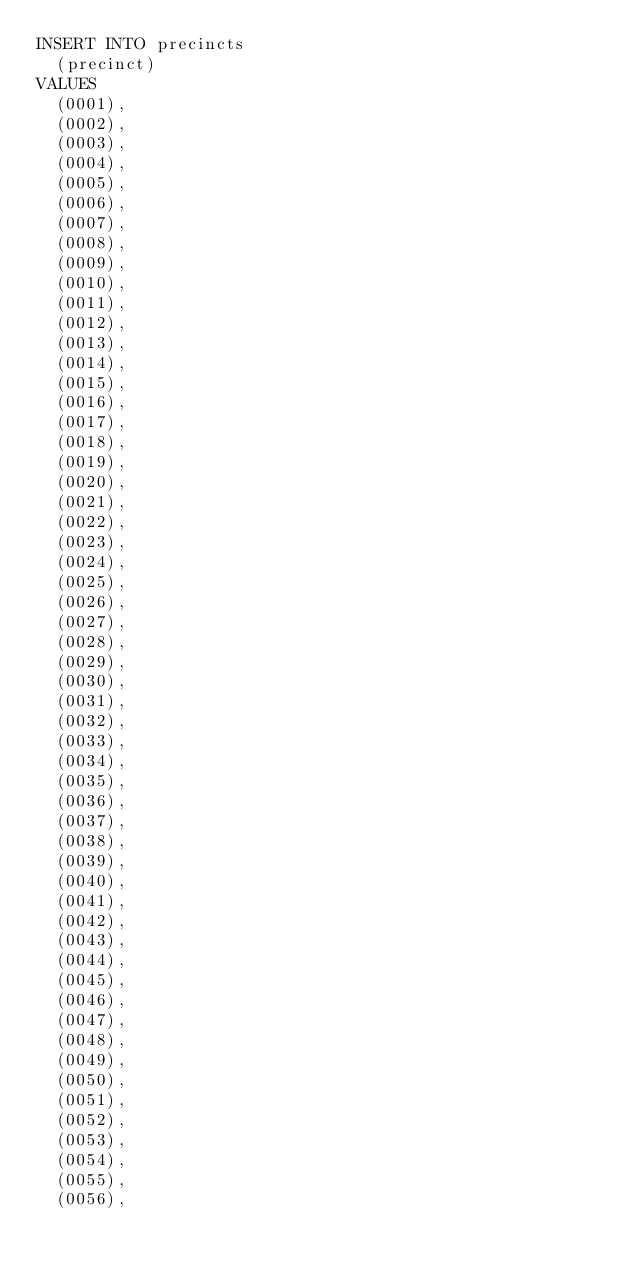<code> <loc_0><loc_0><loc_500><loc_500><_SQL_>INSERT INTO precincts
  (precinct)
VALUES
  (0001),
  (0002),
  (0003),
  (0004),
  (0005),
  (0006),
  (0007),
  (0008),
  (0009),
  (0010),
  (0011),
  (0012),
  (0013),
  (0014),
  (0015),
  (0016),
  (0017),
  (0018),
  (0019),
  (0020),
  (0021),
  (0022),
  (0023),
  (0024),
  (0025),
  (0026),
  (0027),
  (0028),
  (0029),
  (0030),
  (0031),
  (0032),
  (0033),
  (0034),
  (0035),
  (0036),
  (0037),
  (0038),
  (0039),
  (0040),
  (0041),
  (0042),
  (0043),
  (0044),
  (0045),
  (0046),
  (0047),
  (0048),
  (0049),
  (0050),
  (0051),
  (0052),
  (0053),
  (0054),
  (0055),
  (0056),</code> 